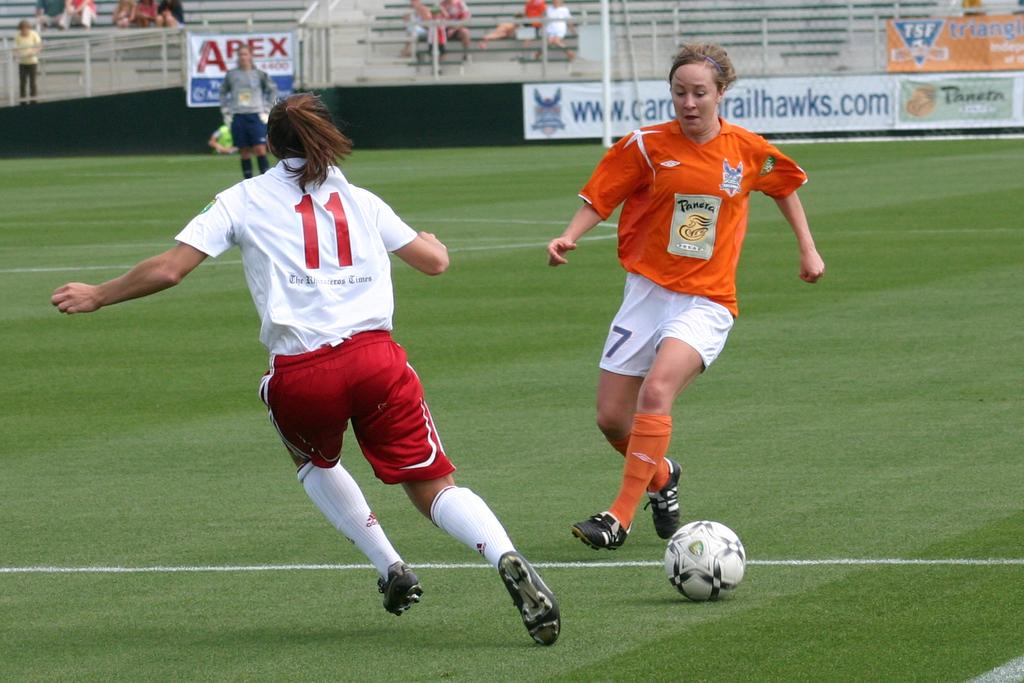<image>
Give a short and clear explanation of the subsequent image. Two female soccer player with number 11 and 7. 